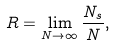<formula> <loc_0><loc_0><loc_500><loc_500>R = \lim _ { N \rightarrow \infty } \frac { N _ { s } } { N } ,</formula> 